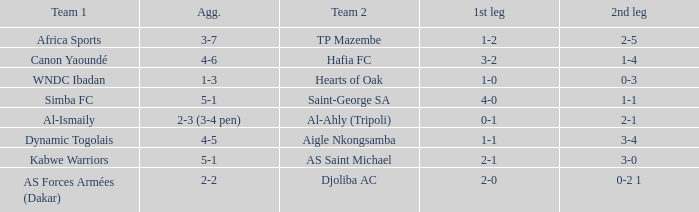Against which team did al-ismaily (team 1) play? Al-Ahly (Tripoli). 